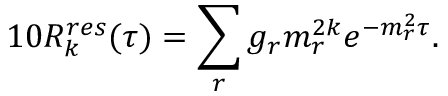Convert formula to latex. <formula><loc_0><loc_0><loc_500><loc_500>1 0 R _ { k } ^ { r e s } ( \tau ) = \sum _ { r } g _ { r } m _ { r } ^ { 2 k } e ^ { - m _ { r } ^ { 2 } \tau } .</formula> 